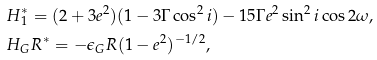Convert formula to latex. <formula><loc_0><loc_0><loc_500><loc_500>& H _ { 1 } ^ { * } = ( 2 + 3 e ^ { 2 } ) ( 1 - 3 \Gamma \cos ^ { 2 } i ) - 1 5 \Gamma e ^ { 2 } \sin ^ { 2 } i \cos 2 \omega , \\ & H _ { G } R ^ { * } = - \epsilon _ { G } R ( 1 - e ^ { 2 } ) ^ { - 1 / 2 } ,</formula> 